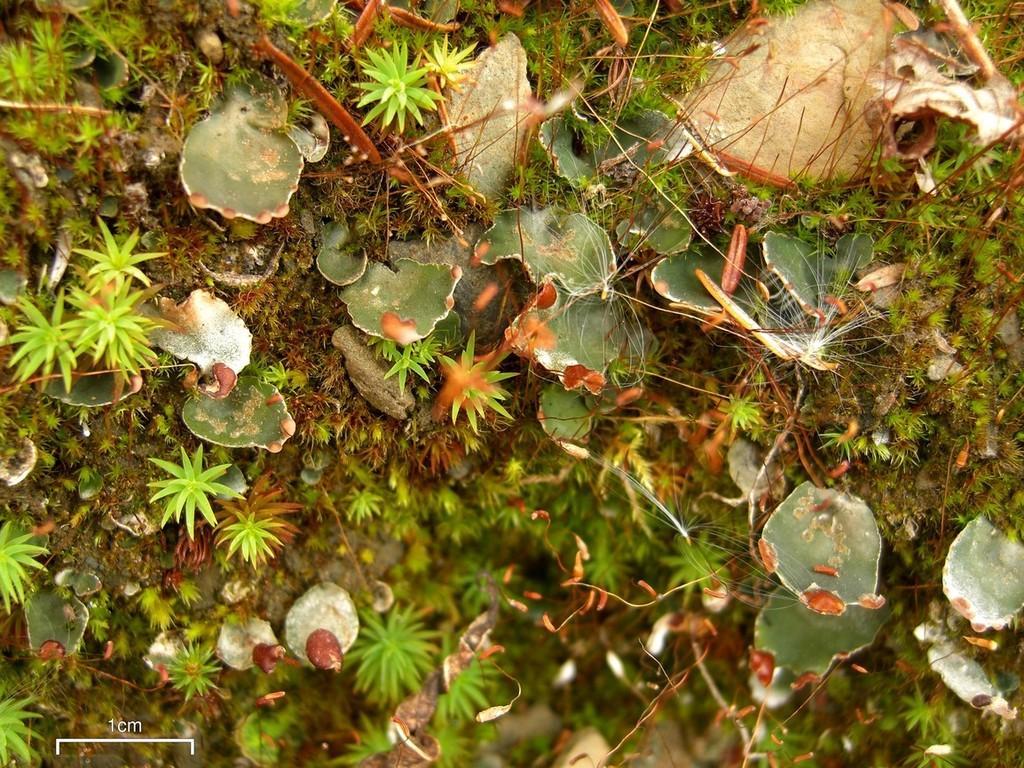In one or two sentences, can you explain what this image depicts? Here we can see plants on the ground and at the bottom the image is blur. 